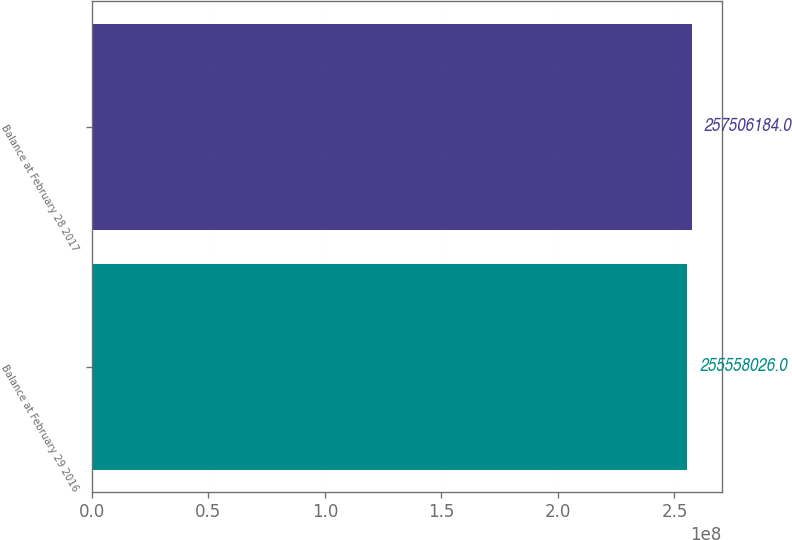<chart> <loc_0><loc_0><loc_500><loc_500><bar_chart><fcel>Balance at February 29 2016<fcel>Balance at February 28 2017<nl><fcel>2.55558e+08<fcel>2.57506e+08<nl></chart> 